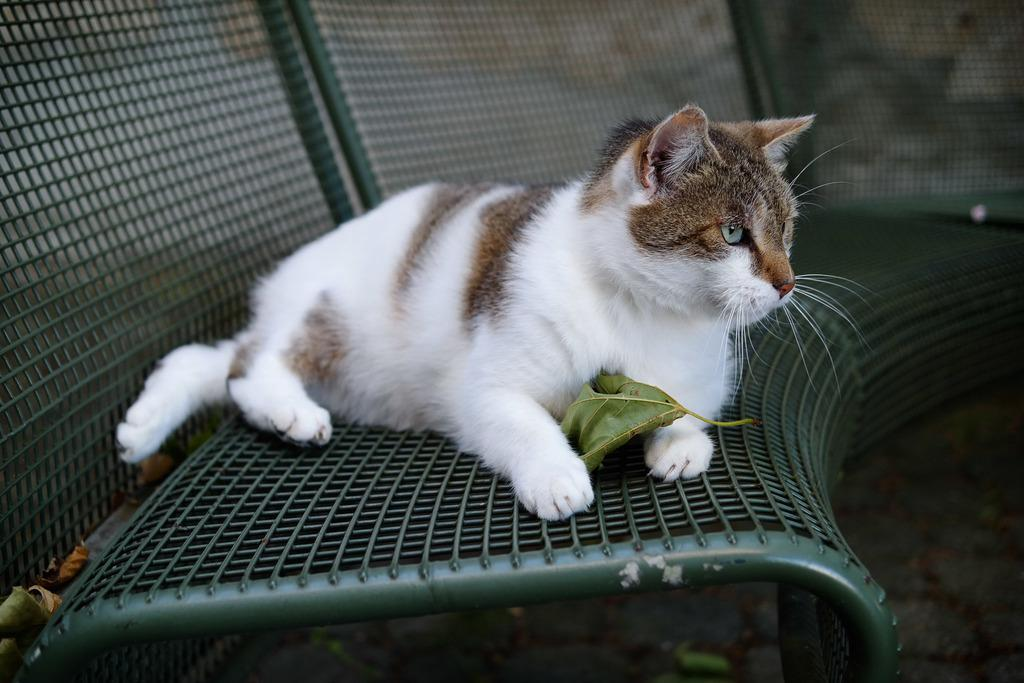What animal is the main subject of the picture? There is a cat in the picture. Where is the cat located in the image? The cat is sitting on a bench. Can you describe the position of the cat in the picture? The cat is in the middle of the picture. What colors can be seen on the cat's fur? The cat has brown and white coloring. What is the weight of the garden in the image? There is no garden present in the image, so it is not possible to determine its weight. 